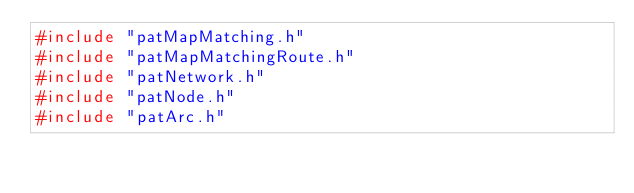Convert code to text. <code><loc_0><loc_0><loc_500><loc_500><_C++_>#include "patMapMatching.h"
#include "patMapMatchingRoute.h"
#include "patNetwork.h"
#include "patNode.h"
#include "patArc.h"</code> 